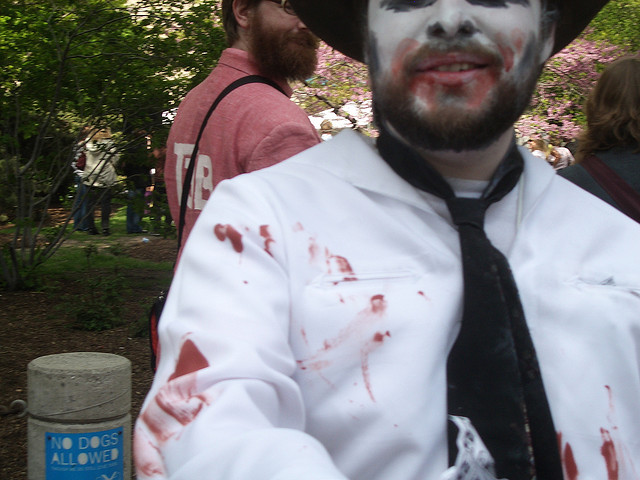Identify the text contained in this image. DOGS ALLOWED 